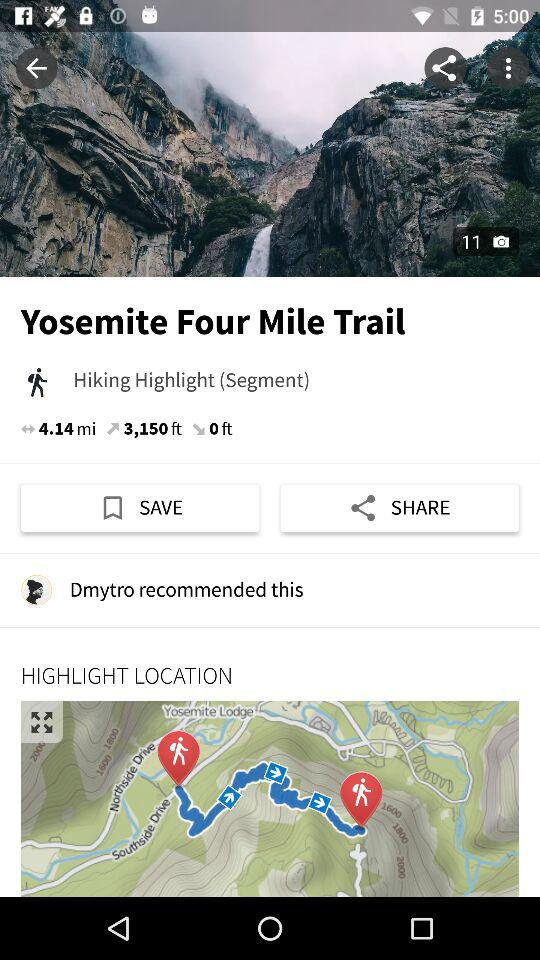What is the number of photos? The number of photos is 11. 